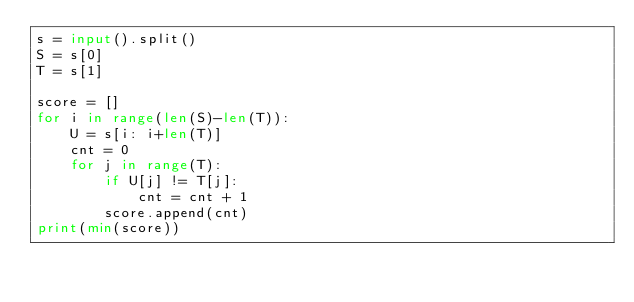Convert code to text. <code><loc_0><loc_0><loc_500><loc_500><_Python_>s = input().split()
S = s[0]
T = s[1]

score = []
for i in range(len(S)-len(T)):
    U = s[i: i+len(T)]
    cnt = 0
    for j in range(T):
        if U[j] != T[j]:
            cnt = cnt + 1
        score.append(cnt)
print(min(score))

</code> 